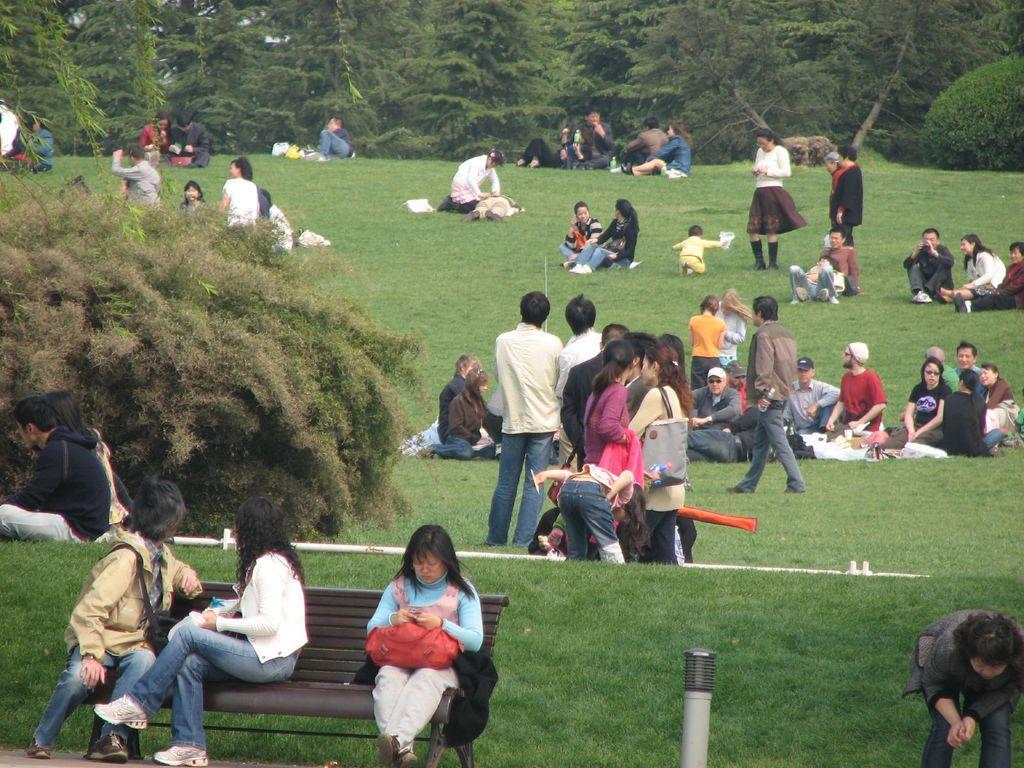Could you give a brief overview of what you see in this image? In this image I can see a ground , on the ground I can see there are few persons and babies visible ,at the bottom there are three persons sitting on bench and a pole visible , on the left side there are some bushes, at the top there are some trees and bushes visible. 